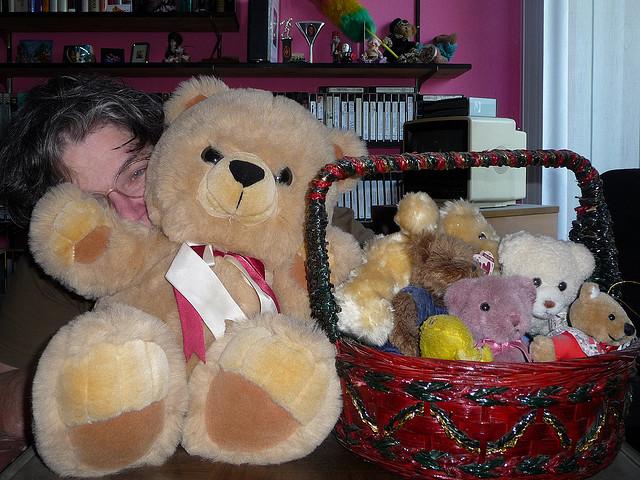What color is the bigger bear?
Quick response, please. Brown. Are there VHS tapes on the back wall?
Write a very short answer. Yes. What is the bear wearing?
Keep it brief. Bow. Who is behind the bear?
Answer briefly. Person. What are the stuffed animals sitting on?
Write a very short answer. Table. Is this teddy bear for sale?
Short answer required. No. What are the bears sitting on?
Give a very brief answer. Basket. Are there toys in the basket?
Be succinct. Yes. 